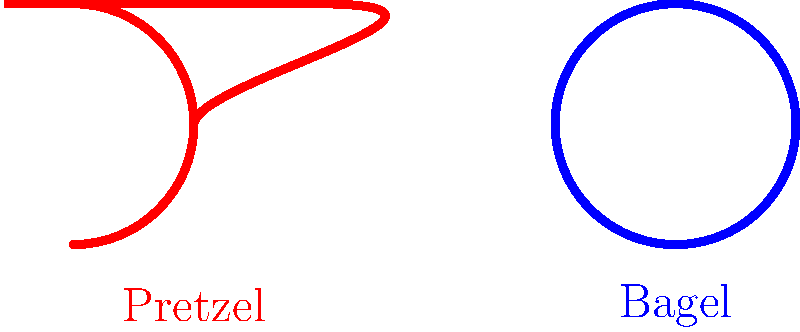As you're watching your neighbor's sick child, you decide to engage them in a fun topology discussion. You show them a picture of a pretzel and a bagel. How would you explain the topological difference between these two shapes in simple terms? To explain the topological difference between a pretzel and a bagel to a child, we can follow these steps:

1. First, let's consider what topology focuses on: the properties of shapes that don't change when the shape is stretched, twisted, or deformed (without tearing or gluing).

2. Now, let's look at the bagel:
   - A bagel has one hole in the middle.
   - If we were to make it out of rubber, we could stretch or squish it, but the hole would always remain.
   - In topology, we call this shape a "torus."

3. Next, let's examine the pretzel:
   - A typical pretzel has three holes.
   - Even if we stretched or twisted the pretzel, it would always have these three holes.
   - In topology, this shape is sometimes called a "three-torus" or a "pretzel surface."

4. The key difference:
   - The number of holes is a topological property that doesn't change under continuous deformations.
   - A bagel (1 hole) can never be transformed into a pretzel (3 holes) without cutting or gluing.

5. In mathematical terms:
   - The genus of a surface is the number of holes it has.
   - A bagel has a genus of 1.
   - A pretzel has a genus of 3.

So, the main topological difference between a pretzel and a bagel is the number of holes, which we call the genus in topology.
Answer: The pretzel has a genus of 3, while the bagel has a genus of 1. 